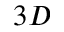Convert formula to latex. <formula><loc_0><loc_0><loc_500><loc_500>3 D</formula> 